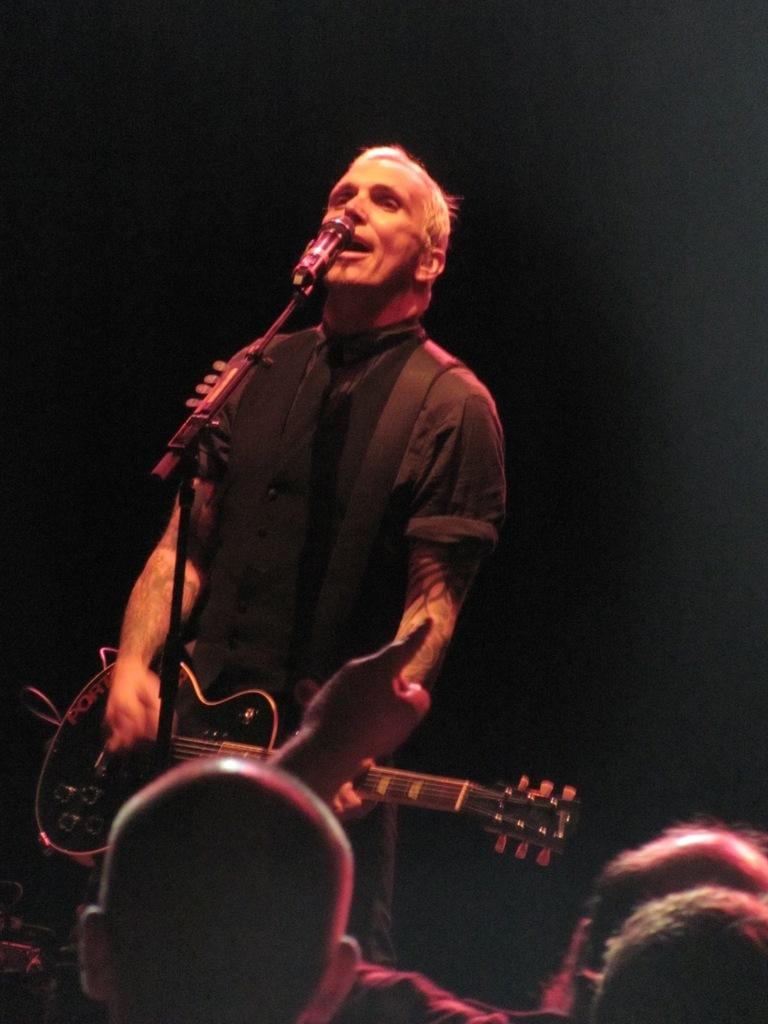What is the main subject of the image? There is a person standing in the center of the image. What is the person holding in the image? The person is holding a guitar. What object is in front of the person? There is a microphone in front of the person. Are there any other people visible in the image? Yes, there are other people standing in the bottom of the image. What type of cover is protecting the cannon in the image? There is no cannon present in the image, so there is no cover protecting it. 